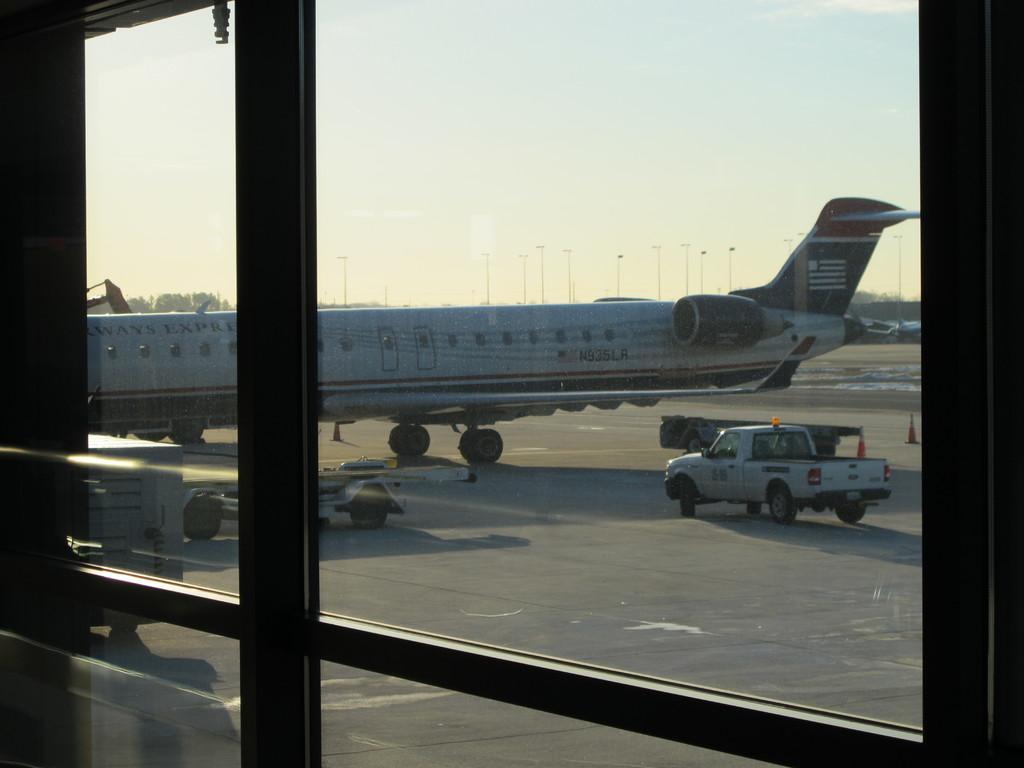Describe this image in one or two sentences. In this image we can see a glass door and behind the glass door we can see a vehicle and also an air plane on the land. Sky is also visible. 